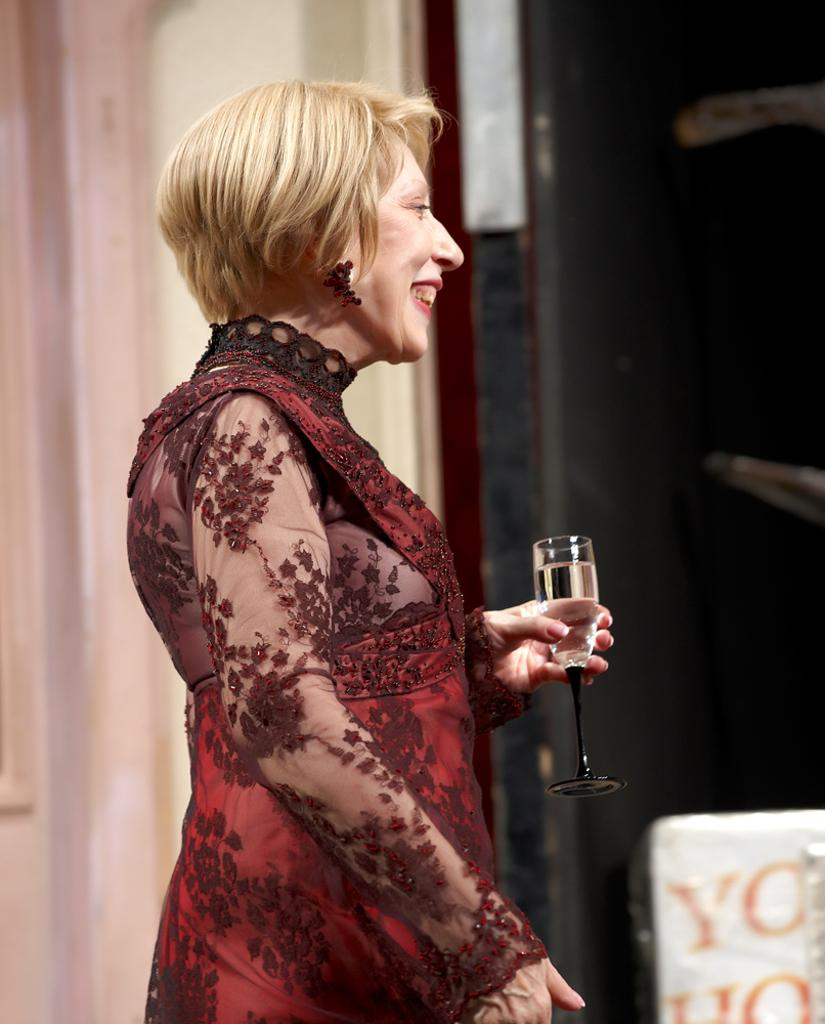Who is the main subject in the image? There is a woman in the image. What is the woman wearing? The woman is wearing a red costume. What is the woman holding in her hand? The woman is holding a wine glass. What is inside the wine glass? The wine glass contains wine. What type of animal is the woman representing in the image? There is no indication in the image that the woman is representing any specific animal. 